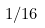Convert formula to latex. <formula><loc_0><loc_0><loc_500><loc_500>1 / 1 6</formula> 